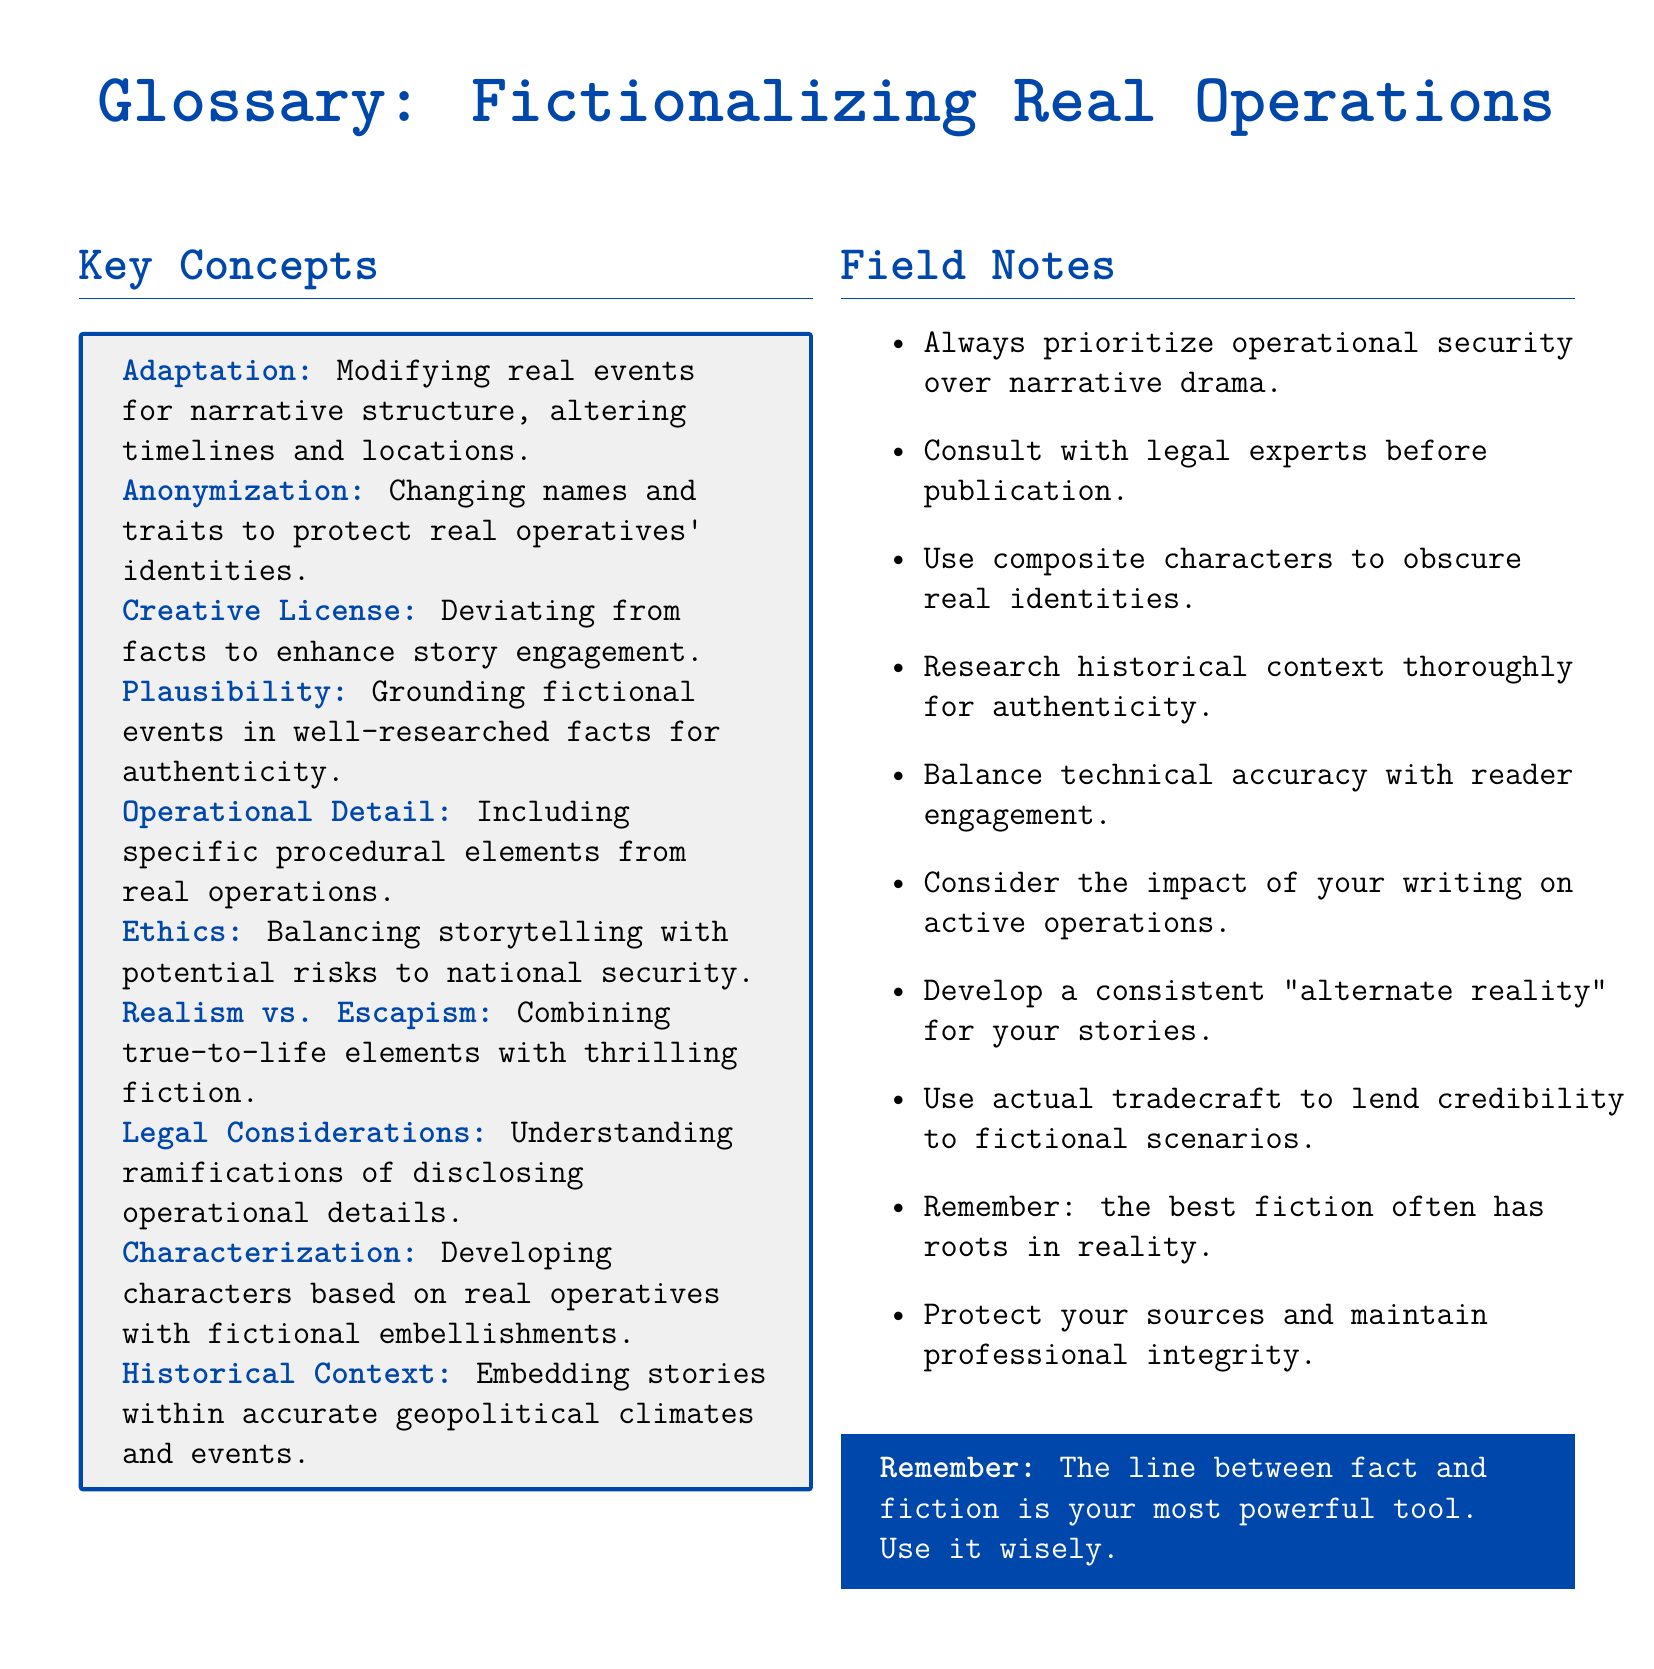What is the term for changing names and traits to protect identities? The document defines the term specifically related to protecting identities of operatives.
Answer: Anonymization What does the term 'Creative License' refer to? In the glossary, 'Creative License' describes the use of alterations from factual events for improved engagement.
Answer: Deviating from facts to enhance story engagement What is emphasized regarding operational security in field notes? The field notes prioritize the importance of operational security over any dramatic narrative aspects.
Answer: Always prioritize operational security over narrative drama What is the purpose of 'Plausibility' in fictionalizing operations? 'Plausibility' is about ensuring that fictional elements are based on thorough research to maintain authenticity.
Answer: Grounding fictional events in well-researched facts for authenticity How should authors approach legal risks when publishing? The field notes mention consulting experts to mitigate legal risks.
Answer: Consult with legal experts before publication What should be developed for consistency in storytelling? The document mentions creating a cohesive framework within the storytelling approach.
Answer: Develop a consistent "alternate reality" What key aspect must be balanced with reader engagement? Technical accuracy is highlighted as a fundamental consideration for engaging storytelling.
Answer: Balance technical accuracy with reader engagement What is the final takeaway about fact and fiction? The conclusion of the glossary mentions the relationship between fact and fiction as a crucial tool for writers.
Answer: The line between fact and fiction is your most powerful tool 